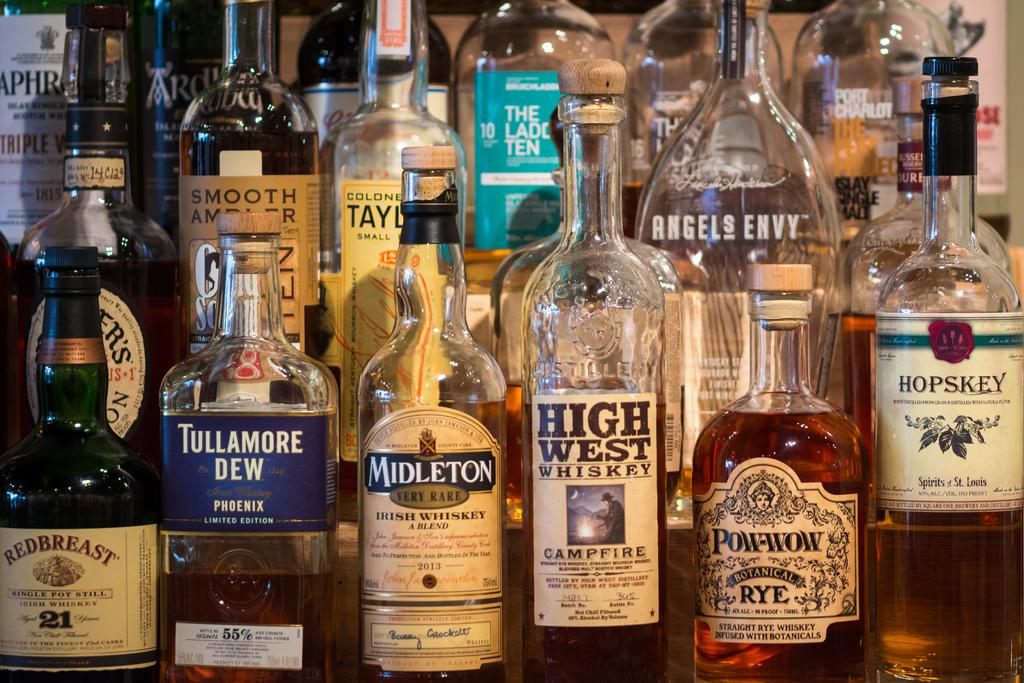What type of containers are present in the image? There are glass bottles in the image. Are all the bottles the same or do they differ? The bottles have different kinds. Can you describe any additional features on the bottles? Some bottles have stickers on them. What is inside some of the bottles? Some bottles contain liquid. How does the car navigate the steep slope in the image? There is no car present in the image; it only features glass bottles. 